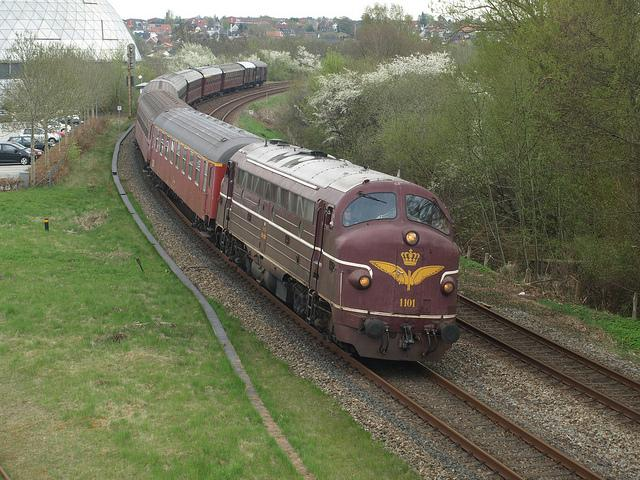What wrestler is named after the long item with the wing logo? Please explain your reasoning. a-train. A-train is the name of the wrestler. 